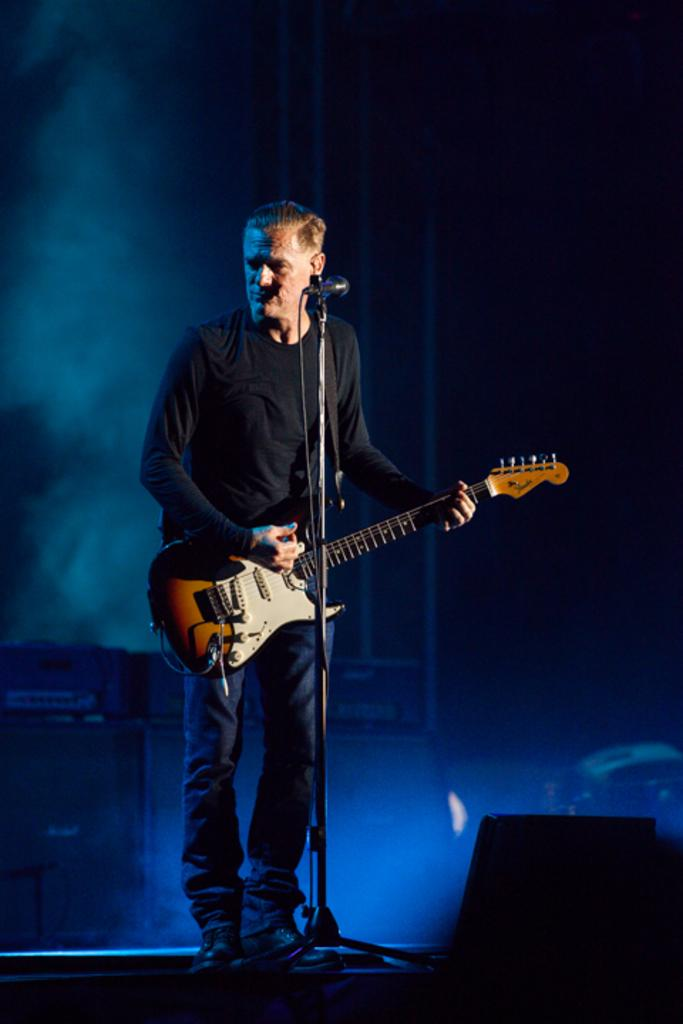What is the main subject of the image? The main subject of the image is a man standing in the middle. What is the man doing in the image? The man is playing a guitar in the image. What object is also present in the middle of the image? There is a microphone in the middle of the image. Can you see any jellyfish swimming near the man in the image? There are no jellyfish present in the image; it features a man playing a guitar and a microphone. What rule is being enforced by the man in the image? There is no indication of any rule enforcement in the image; the man is playing a guitar. 